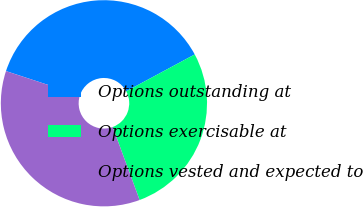Convert chart. <chart><loc_0><loc_0><loc_500><loc_500><pie_chart><fcel>Options outstanding at<fcel>Options exercisable at<fcel>Options vested and expected to<nl><fcel>37.09%<fcel>27.23%<fcel>35.68%<nl></chart> 